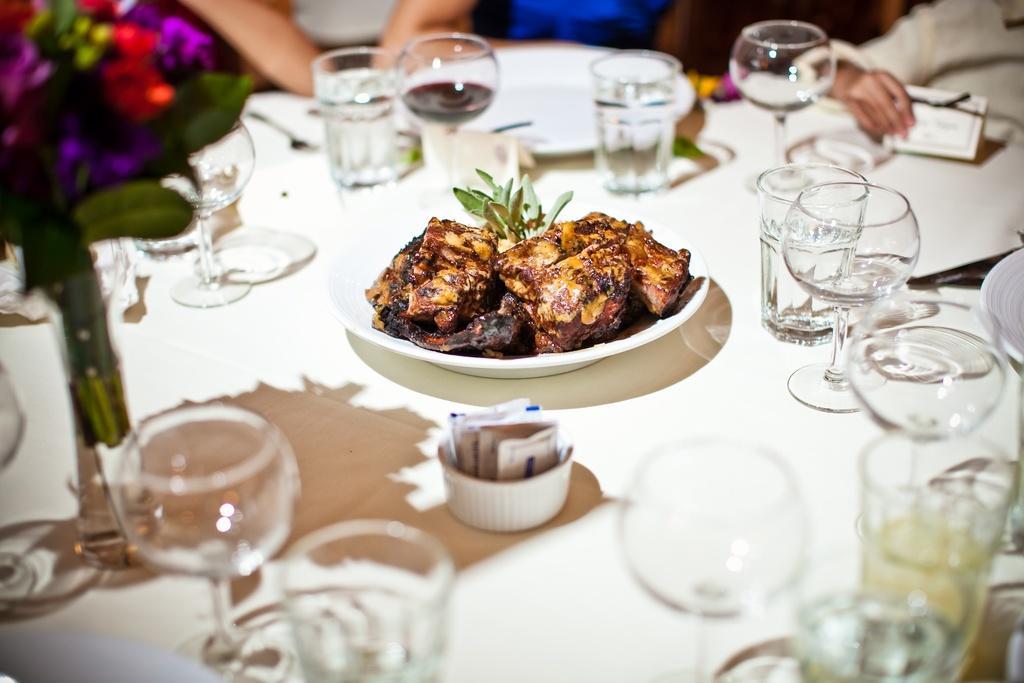Could you give a brief overview of what you see in this image? In this image there is a table and we can see glasses, plates, bowl, flower vase, board, spoons and a plate containing food placed on the table. In the background there are people. 